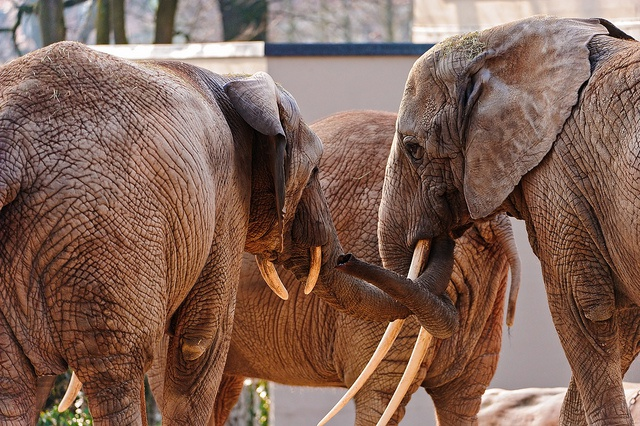Describe the objects in this image and their specific colors. I can see elephant in pink, maroon, gray, black, and brown tones, elephant in pink, maroon, gray, black, and brown tones, and elephant in pink, maroon, brown, and gray tones in this image. 